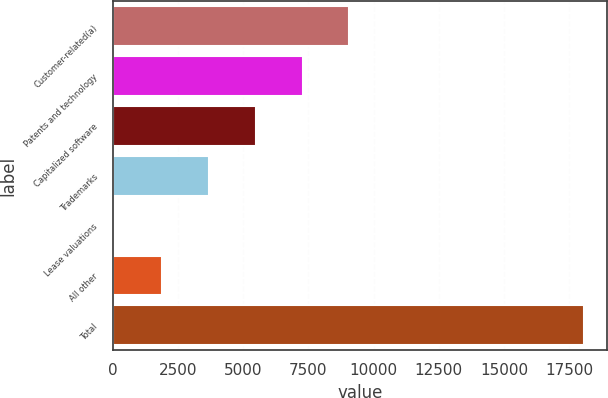Convert chart to OTSL. <chart><loc_0><loc_0><loc_500><loc_500><bar_chart><fcel>Customer-related(a)<fcel>Patents and technology<fcel>Capitalized software<fcel>Trademarks<fcel>Lease valuations<fcel>All other<fcel>Total<nl><fcel>9072.5<fcel>7275.8<fcel>5479.1<fcel>3682.4<fcel>89<fcel>1885.7<fcel>18056<nl></chart> 